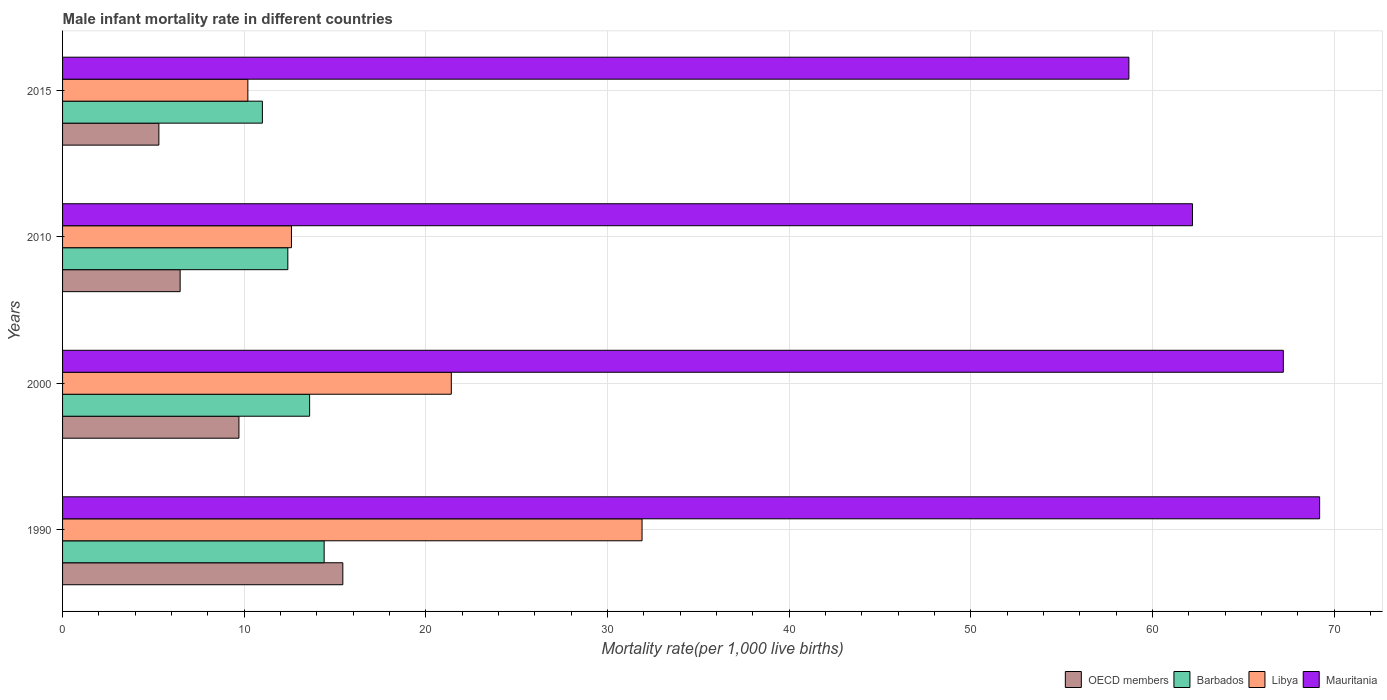How many groups of bars are there?
Your response must be concise. 4. Are the number of bars on each tick of the Y-axis equal?
Make the answer very short. Yes. How many bars are there on the 1st tick from the bottom?
Keep it short and to the point. 4. What is the label of the 1st group of bars from the top?
Make the answer very short. 2015. In how many cases, is the number of bars for a given year not equal to the number of legend labels?
Your response must be concise. 0. What is the male infant mortality rate in OECD members in 2015?
Offer a very short reply. 5.3. Across all years, what is the maximum male infant mortality rate in Mauritania?
Give a very brief answer. 69.2. Across all years, what is the minimum male infant mortality rate in OECD members?
Give a very brief answer. 5.3. In which year was the male infant mortality rate in Mauritania minimum?
Offer a terse response. 2015. What is the total male infant mortality rate in OECD members in the graph?
Your answer should be compact. 36.91. What is the difference between the male infant mortality rate in Mauritania in 1990 and that in 2000?
Provide a succinct answer. 2. What is the difference between the male infant mortality rate in Barbados in 2010 and the male infant mortality rate in Mauritania in 2000?
Your answer should be compact. -54.8. What is the average male infant mortality rate in Mauritania per year?
Your answer should be very brief. 64.33. In the year 2000, what is the difference between the male infant mortality rate in Mauritania and male infant mortality rate in OECD members?
Offer a terse response. 57.49. What is the ratio of the male infant mortality rate in Barbados in 1990 to that in 2000?
Give a very brief answer. 1.06. What is the difference between the highest and the second highest male infant mortality rate in OECD members?
Provide a succinct answer. 5.72. What is the difference between the highest and the lowest male infant mortality rate in Libya?
Keep it short and to the point. 21.7. What does the 2nd bar from the top in 2015 represents?
Offer a terse response. Libya. What does the 1st bar from the bottom in 1990 represents?
Provide a short and direct response. OECD members. Is it the case that in every year, the sum of the male infant mortality rate in Libya and male infant mortality rate in OECD members is greater than the male infant mortality rate in Barbados?
Your answer should be very brief. Yes. Are all the bars in the graph horizontal?
Your answer should be compact. Yes. How many years are there in the graph?
Offer a very short reply. 4. What is the difference between two consecutive major ticks on the X-axis?
Make the answer very short. 10. Are the values on the major ticks of X-axis written in scientific E-notation?
Ensure brevity in your answer.  No. Does the graph contain any zero values?
Your answer should be compact. No. Where does the legend appear in the graph?
Your answer should be compact. Bottom right. How many legend labels are there?
Keep it short and to the point. 4. How are the legend labels stacked?
Your answer should be compact. Horizontal. What is the title of the graph?
Make the answer very short. Male infant mortality rate in different countries. What is the label or title of the X-axis?
Offer a very short reply. Mortality rate(per 1,0 live births). What is the Mortality rate(per 1,000 live births) of OECD members in 1990?
Ensure brevity in your answer.  15.43. What is the Mortality rate(per 1,000 live births) in Barbados in 1990?
Ensure brevity in your answer.  14.4. What is the Mortality rate(per 1,000 live births) in Libya in 1990?
Give a very brief answer. 31.9. What is the Mortality rate(per 1,000 live births) of Mauritania in 1990?
Your answer should be compact. 69.2. What is the Mortality rate(per 1,000 live births) in OECD members in 2000?
Ensure brevity in your answer.  9.71. What is the Mortality rate(per 1,000 live births) of Barbados in 2000?
Make the answer very short. 13.6. What is the Mortality rate(per 1,000 live births) of Libya in 2000?
Offer a terse response. 21.4. What is the Mortality rate(per 1,000 live births) in Mauritania in 2000?
Provide a succinct answer. 67.2. What is the Mortality rate(per 1,000 live births) in OECD members in 2010?
Make the answer very short. 6.47. What is the Mortality rate(per 1,000 live births) in Libya in 2010?
Ensure brevity in your answer.  12.6. What is the Mortality rate(per 1,000 live births) of Mauritania in 2010?
Make the answer very short. 62.2. What is the Mortality rate(per 1,000 live births) of OECD members in 2015?
Give a very brief answer. 5.3. What is the Mortality rate(per 1,000 live births) in Libya in 2015?
Keep it short and to the point. 10.2. What is the Mortality rate(per 1,000 live births) in Mauritania in 2015?
Offer a terse response. 58.7. Across all years, what is the maximum Mortality rate(per 1,000 live births) of OECD members?
Make the answer very short. 15.43. Across all years, what is the maximum Mortality rate(per 1,000 live births) in Libya?
Make the answer very short. 31.9. Across all years, what is the maximum Mortality rate(per 1,000 live births) in Mauritania?
Keep it short and to the point. 69.2. Across all years, what is the minimum Mortality rate(per 1,000 live births) in OECD members?
Provide a short and direct response. 5.3. Across all years, what is the minimum Mortality rate(per 1,000 live births) in Barbados?
Ensure brevity in your answer.  11. Across all years, what is the minimum Mortality rate(per 1,000 live births) in Libya?
Make the answer very short. 10.2. Across all years, what is the minimum Mortality rate(per 1,000 live births) in Mauritania?
Your answer should be compact. 58.7. What is the total Mortality rate(per 1,000 live births) of OECD members in the graph?
Offer a terse response. 36.91. What is the total Mortality rate(per 1,000 live births) of Barbados in the graph?
Your response must be concise. 51.4. What is the total Mortality rate(per 1,000 live births) of Libya in the graph?
Provide a short and direct response. 76.1. What is the total Mortality rate(per 1,000 live births) in Mauritania in the graph?
Your response must be concise. 257.3. What is the difference between the Mortality rate(per 1,000 live births) in OECD members in 1990 and that in 2000?
Make the answer very short. 5.72. What is the difference between the Mortality rate(per 1,000 live births) of OECD members in 1990 and that in 2010?
Offer a very short reply. 8.96. What is the difference between the Mortality rate(per 1,000 live births) in Libya in 1990 and that in 2010?
Provide a succinct answer. 19.3. What is the difference between the Mortality rate(per 1,000 live births) of OECD members in 1990 and that in 2015?
Offer a terse response. 10.13. What is the difference between the Mortality rate(per 1,000 live births) of Libya in 1990 and that in 2015?
Your answer should be very brief. 21.7. What is the difference between the Mortality rate(per 1,000 live births) of Mauritania in 1990 and that in 2015?
Provide a short and direct response. 10.5. What is the difference between the Mortality rate(per 1,000 live births) in OECD members in 2000 and that in 2010?
Keep it short and to the point. 3.24. What is the difference between the Mortality rate(per 1,000 live births) in Barbados in 2000 and that in 2010?
Provide a short and direct response. 1.2. What is the difference between the Mortality rate(per 1,000 live births) in Mauritania in 2000 and that in 2010?
Make the answer very short. 5. What is the difference between the Mortality rate(per 1,000 live births) of OECD members in 2000 and that in 2015?
Ensure brevity in your answer.  4.41. What is the difference between the Mortality rate(per 1,000 live births) in Libya in 2000 and that in 2015?
Your answer should be very brief. 11.2. What is the difference between the Mortality rate(per 1,000 live births) of OECD members in 2010 and that in 2015?
Provide a succinct answer. 1.17. What is the difference between the Mortality rate(per 1,000 live births) of Barbados in 2010 and that in 2015?
Give a very brief answer. 1.4. What is the difference between the Mortality rate(per 1,000 live births) in Libya in 2010 and that in 2015?
Give a very brief answer. 2.4. What is the difference between the Mortality rate(per 1,000 live births) in Mauritania in 2010 and that in 2015?
Offer a terse response. 3.5. What is the difference between the Mortality rate(per 1,000 live births) of OECD members in 1990 and the Mortality rate(per 1,000 live births) of Barbados in 2000?
Keep it short and to the point. 1.83. What is the difference between the Mortality rate(per 1,000 live births) of OECD members in 1990 and the Mortality rate(per 1,000 live births) of Libya in 2000?
Offer a terse response. -5.97. What is the difference between the Mortality rate(per 1,000 live births) of OECD members in 1990 and the Mortality rate(per 1,000 live births) of Mauritania in 2000?
Ensure brevity in your answer.  -51.77. What is the difference between the Mortality rate(per 1,000 live births) in Barbados in 1990 and the Mortality rate(per 1,000 live births) in Mauritania in 2000?
Ensure brevity in your answer.  -52.8. What is the difference between the Mortality rate(per 1,000 live births) in Libya in 1990 and the Mortality rate(per 1,000 live births) in Mauritania in 2000?
Ensure brevity in your answer.  -35.3. What is the difference between the Mortality rate(per 1,000 live births) of OECD members in 1990 and the Mortality rate(per 1,000 live births) of Barbados in 2010?
Ensure brevity in your answer.  3.03. What is the difference between the Mortality rate(per 1,000 live births) of OECD members in 1990 and the Mortality rate(per 1,000 live births) of Libya in 2010?
Ensure brevity in your answer.  2.83. What is the difference between the Mortality rate(per 1,000 live births) in OECD members in 1990 and the Mortality rate(per 1,000 live births) in Mauritania in 2010?
Provide a short and direct response. -46.77. What is the difference between the Mortality rate(per 1,000 live births) in Barbados in 1990 and the Mortality rate(per 1,000 live births) in Libya in 2010?
Provide a short and direct response. 1.8. What is the difference between the Mortality rate(per 1,000 live births) in Barbados in 1990 and the Mortality rate(per 1,000 live births) in Mauritania in 2010?
Provide a succinct answer. -47.8. What is the difference between the Mortality rate(per 1,000 live births) of Libya in 1990 and the Mortality rate(per 1,000 live births) of Mauritania in 2010?
Offer a very short reply. -30.3. What is the difference between the Mortality rate(per 1,000 live births) in OECD members in 1990 and the Mortality rate(per 1,000 live births) in Barbados in 2015?
Provide a short and direct response. 4.43. What is the difference between the Mortality rate(per 1,000 live births) of OECD members in 1990 and the Mortality rate(per 1,000 live births) of Libya in 2015?
Provide a succinct answer. 5.23. What is the difference between the Mortality rate(per 1,000 live births) in OECD members in 1990 and the Mortality rate(per 1,000 live births) in Mauritania in 2015?
Offer a very short reply. -43.27. What is the difference between the Mortality rate(per 1,000 live births) in Barbados in 1990 and the Mortality rate(per 1,000 live births) in Libya in 2015?
Your response must be concise. 4.2. What is the difference between the Mortality rate(per 1,000 live births) in Barbados in 1990 and the Mortality rate(per 1,000 live births) in Mauritania in 2015?
Offer a very short reply. -44.3. What is the difference between the Mortality rate(per 1,000 live births) of Libya in 1990 and the Mortality rate(per 1,000 live births) of Mauritania in 2015?
Provide a succinct answer. -26.8. What is the difference between the Mortality rate(per 1,000 live births) of OECD members in 2000 and the Mortality rate(per 1,000 live births) of Barbados in 2010?
Offer a very short reply. -2.69. What is the difference between the Mortality rate(per 1,000 live births) in OECD members in 2000 and the Mortality rate(per 1,000 live births) in Libya in 2010?
Offer a very short reply. -2.89. What is the difference between the Mortality rate(per 1,000 live births) of OECD members in 2000 and the Mortality rate(per 1,000 live births) of Mauritania in 2010?
Your response must be concise. -52.49. What is the difference between the Mortality rate(per 1,000 live births) in Barbados in 2000 and the Mortality rate(per 1,000 live births) in Libya in 2010?
Provide a succinct answer. 1. What is the difference between the Mortality rate(per 1,000 live births) in Barbados in 2000 and the Mortality rate(per 1,000 live births) in Mauritania in 2010?
Your answer should be compact. -48.6. What is the difference between the Mortality rate(per 1,000 live births) of Libya in 2000 and the Mortality rate(per 1,000 live births) of Mauritania in 2010?
Your answer should be compact. -40.8. What is the difference between the Mortality rate(per 1,000 live births) in OECD members in 2000 and the Mortality rate(per 1,000 live births) in Barbados in 2015?
Keep it short and to the point. -1.29. What is the difference between the Mortality rate(per 1,000 live births) in OECD members in 2000 and the Mortality rate(per 1,000 live births) in Libya in 2015?
Your answer should be compact. -0.49. What is the difference between the Mortality rate(per 1,000 live births) in OECD members in 2000 and the Mortality rate(per 1,000 live births) in Mauritania in 2015?
Offer a terse response. -48.99. What is the difference between the Mortality rate(per 1,000 live births) in Barbados in 2000 and the Mortality rate(per 1,000 live births) in Libya in 2015?
Your response must be concise. 3.4. What is the difference between the Mortality rate(per 1,000 live births) of Barbados in 2000 and the Mortality rate(per 1,000 live births) of Mauritania in 2015?
Keep it short and to the point. -45.1. What is the difference between the Mortality rate(per 1,000 live births) in Libya in 2000 and the Mortality rate(per 1,000 live births) in Mauritania in 2015?
Your answer should be compact. -37.3. What is the difference between the Mortality rate(per 1,000 live births) in OECD members in 2010 and the Mortality rate(per 1,000 live births) in Barbados in 2015?
Offer a terse response. -4.53. What is the difference between the Mortality rate(per 1,000 live births) in OECD members in 2010 and the Mortality rate(per 1,000 live births) in Libya in 2015?
Make the answer very short. -3.73. What is the difference between the Mortality rate(per 1,000 live births) of OECD members in 2010 and the Mortality rate(per 1,000 live births) of Mauritania in 2015?
Provide a short and direct response. -52.23. What is the difference between the Mortality rate(per 1,000 live births) in Barbados in 2010 and the Mortality rate(per 1,000 live births) in Mauritania in 2015?
Offer a very short reply. -46.3. What is the difference between the Mortality rate(per 1,000 live births) of Libya in 2010 and the Mortality rate(per 1,000 live births) of Mauritania in 2015?
Your answer should be very brief. -46.1. What is the average Mortality rate(per 1,000 live births) in OECD members per year?
Give a very brief answer. 9.23. What is the average Mortality rate(per 1,000 live births) of Barbados per year?
Offer a very short reply. 12.85. What is the average Mortality rate(per 1,000 live births) in Libya per year?
Your response must be concise. 19.02. What is the average Mortality rate(per 1,000 live births) in Mauritania per year?
Give a very brief answer. 64.33. In the year 1990, what is the difference between the Mortality rate(per 1,000 live births) in OECD members and Mortality rate(per 1,000 live births) in Barbados?
Keep it short and to the point. 1.03. In the year 1990, what is the difference between the Mortality rate(per 1,000 live births) of OECD members and Mortality rate(per 1,000 live births) of Libya?
Make the answer very short. -16.47. In the year 1990, what is the difference between the Mortality rate(per 1,000 live births) in OECD members and Mortality rate(per 1,000 live births) in Mauritania?
Provide a succinct answer. -53.77. In the year 1990, what is the difference between the Mortality rate(per 1,000 live births) in Barbados and Mortality rate(per 1,000 live births) in Libya?
Ensure brevity in your answer.  -17.5. In the year 1990, what is the difference between the Mortality rate(per 1,000 live births) of Barbados and Mortality rate(per 1,000 live births) of Mauritania?
Offer a very short reply. -54.8. In the year 1990, what is the difference between the Mortality rate(per 1,000 live births) of Libya and Mortality rate(per 1,000 live births) of Mauritania?
Provide a short and direct response. -37.3. In the year 2000, what is the difference between the Mortality rate(per 1,000 live births) of OECD members and Mortality rate(per 1,000 live births) of Barbados?
Provide a succinct answer. -3.89. In the year 2000, what is the difference between the Mortality rate(per 1,000 live births) in OECD members and Mortality rate(per 1,000 live births) in Libya?
Give a very brief answer. -11.69. In the year 2000, what is the difference between the Mortality rate(per 1,000 live births) in OECD members and Mortality rate(per 1,000 live births) in Mauritania?
Your response must be concise. -57.49. In the year 2000, what is the difference between the Mortality rate(per 1,000 live births) of Barbados and Mortality rate(per 1,000 live births) of Libya?
Provide a short and direct response. -7.8. In the year 2000, what is the difference between the Mortality rate(per 1,000 live births) in Barbados and Mortality rate(per 1,000 live births) in Mauritania?
Ensure brevity in your answer.  -53.6. In the year 2000, what is the difference between the Mortality rate(per 1,000 live births) in Libya and Mortality rate(per 1,000 live births) in Mauritania?
Ensure brevity in your answer.  -45.8. In the year 2010, what is the difference between the Mortality rate(per 1,000 live births) of OECD members and Mortality rate(per 1,000 live births) of Barbados?
Offer a terse response. -5.93. In the year 2010, what is the difference between the Mortality rate(per 1,000 live births) in OECD members and Mortality rate(per 1,000 live births) in Libya?
Keep it short and to the point. -6.13. In the year 2010, what is the difference between the Mortality rate(per 1,000 live births) in OECD members and Mortality rate(per 1,000 live births) in Mauritania?
Make the answer very short. -55.73. In the year 2010, what is the difference between the Mortality rate(per 1,000 live births) in Barbados and Mortality rate(per 1,000 live births) in Libya?
Keep it short and to the point. -0.2. In the year 2010, what is the difference between the Mortality rate(per 1,000 live births) in Barbados and Mortality rate(per 1,000 live births) in Mauritania?
Offer a terse response. -49.8. In the year 2010, what is the difference between the Mortality rate(per 1,000 live births) of Libya and Mortality rate(per 1,000 live births) of Mauritania?
Make the answer very short. -49.6. In the year 2015, what is the difference between the Mortality rate(per 1,000 live births) in OECD members and Mortality rate(per 1,000 live births) in Barbados?
Your response must be concise. -5.7. In the year 2015, what is the difference between the Mortality rate(per 1,000 live births) in OECD members and Mortality rate(per 1,000 live births) in Libya?
Give a very brief answer. -4.9. In the year 2015, what is the difference between the Mortality rate(per 1,000 live births) of OECD members and Mortality rate(per 1,000 live births) of Mauritania?
Offer a terse response. -53.4. In the year 2015, what is the difference between the Mortality rate(per 1,000 live births) of Barbados and Mortality rate(per 1,000 live births) of Libya?
Your answer should be very brief. 0.8. In the year 2015, what is the difference between the Mortality rate(per 1,000 live births) of Barbados and Mortality rate(per 1,000 live births) of Mauritania?
Offer a terse response. -47.7. In the year 2015, what is the difference between the Mortality rate(per 1,000 live births) in Libya and Mortality rate(per 1,000 live births) in Mauritania?
Your answer should be compact. -48.5. What is the ratio of the Mortality rate(per 1,000 live births) in OECD members in 1990 to that in 2000?
Offer a very short reply. 1.59. What is the ratio of the Mortality rate(per 1,000 live births) in Barbados in 1990 to that in 2000?
Offer a very short reply. 1.06. What is the ratio of the Mortality rate(per 1,000 live births) of Libya in 1990 to that in 2000?
Provide a short and direct response. 1.49. What is the ratio of the Mortality rate(per 1,000 live births) in Mauritania in 1990 to that in 2000?
Offer a very short reply. 1.03. What is the ratio of the Mortality rate(per 1,000 live births) of OECD members in 1990 to that in 2010?
Ensure brevity in your answer.  2.38. What is the ratio of the Mortality rate(per 1,000 live births) in Barbados in 1990 to that in 2010?
Ensure brevity in your answer.  1.16. What is the ratio of the Mortality rate(per 1,000 live births) in Libya in 1990 to that in 2010?
Your answer should be very brief. 2.53. What is the ratio of the Mortality rate(per 1,000 live births) of Mauritania in 1990 to that in 2010?
Keep it short and to the point. 1.11. What is the ratio of the Mortality rate(per 1,000 live births) of OECD members in 1990 to that in 2015?
Your response must be concise. 2.91. What is the ratio of the Mortality rate(per 1,000 live births) of Barbados in 1990 to that in 2015?
Ensure brevity in your answer.  1.31. What is the ratio of the Mortality rate(per 1,000 live births) of Libya in 1990 to that in 2015?
Your response must be concise. 3.13. What is the ratio of the Mortality rate(per 1,000 live births) in Mauritania in 1990 to that in 2015?
Ensure brevity in your answer.  1.18. What is the ratio of the Mortality rate(per 1,000 live births) in OECD members in 2000 to that in 2010?
Keep it short and to the point. 1.5. What is the ratio of the Mortality rate(per 1,000 live births) in Barbados in 2000 to that in 2010?
Offer a terse response. 1.1. What is the ratio of the Mortality rate(per 1,000 live births) in Libya in 2000 to that in 2010?
Your answer should be very brief. 1.7. What is the ratio of the Mortality rate(per 1,000 live births) in Mauritania in 2000 to that in 2010?
Your response must be concise. 1.08. What is the ratio of the Mortality rate(per 1,000 live births) of OECD members in 2000 to that in 2015?
Offer a very short reply. 1.83. What is the ratio of the Mortality rate(per 1,000 live births) of Barbados in 2000 to that in 2015?
Offer a very short reply. 1.24. What is the ratio of the Mortality rate(per 1,000 live births) of Libya in 2000 to that in 2015?
Keep it short and to the point. 2.1. What is the ratio of the Mortality rate(per 1,000 live births) of Mauritania in 2000 to that in 2015?
Make the answer very short. 1.14. What is the ratio of the Mortality rate(per 1,000 live births) of OECD members in 2010 to that in 2015?
Provide a short and direct response. 1.22. What is the ratio of the Mortality rate(per 1,000 live births) of Barbados in 2010 to that in 2015?
Offer a very short reply. 1.13. What is the ratio of the Mortality rate(per 1,000 live births) in Libya in 2010 to that in 2015?
Offer a very short reply. 1.24. What is the ratio of the Mortality rate(per 1,000 live births) in Mauritania in 2010 to that in 2015?
Offer a terse response. 1.06. What is the difference between the highest and the second highest Mortality rate(per 1,000 live births) of OECD members?
Provide a succinct answer. 5.72. What is the difference between the highest and the second highest Mortality rate(per 1,000 live births) in Mauritania?
Make the answer very short. 2. What is the difference between the highest and the lowest Mortality rate(per 1,000 live births) in OECD members?
Your answer should be very brief. 10.13. What is the difference between the highest and the lowest Mortality rate(per 1,000 live births) of Barbados?
Ensure brevity in your answer.  3.4. What is the difference between the highest and the lowest Mortality rate(per 1,000 live births) of Libya?
Offer a very short reply. 21.7. 